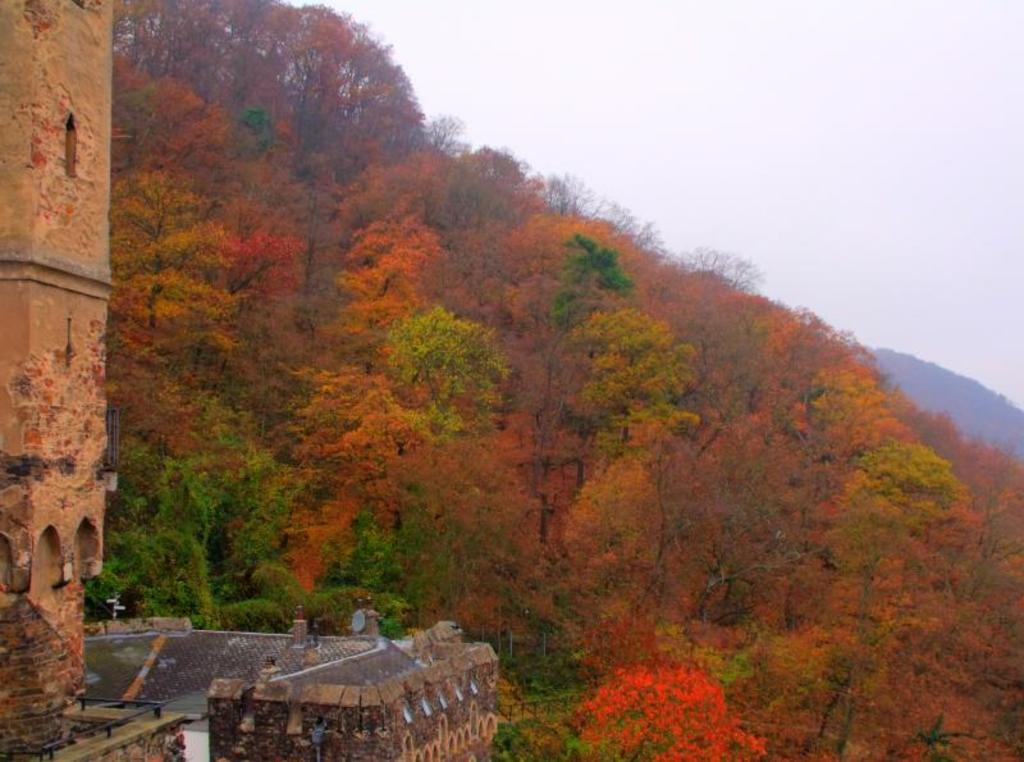What is the main structure visible in the image? There is a building in the image. What can be seen in the background of the image? There are trees in the background of the image. What colors are the trees displaying? The trees have green and orange colors. What is the color of the sky in the image? The sky is white in color. What grade did the father receive in the image? There is no father or grade present in the image. 